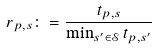Convert formula to latex. <formula><loc_0><loc_0><loc_500><loc_500>r _ { p , s } \colon = \frac { t _ { p , s } } { \min _ { s ^ { \prime } \in \mathcal { S } } t _ { p , s ^ { \prime } } }</formula> 